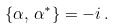Convert formula to latex. <formula><loc_0><loc_0><loc_500><loc_500>\{ \alpha , \, \alpha ^ { * } \} = - i \, .</formula> 